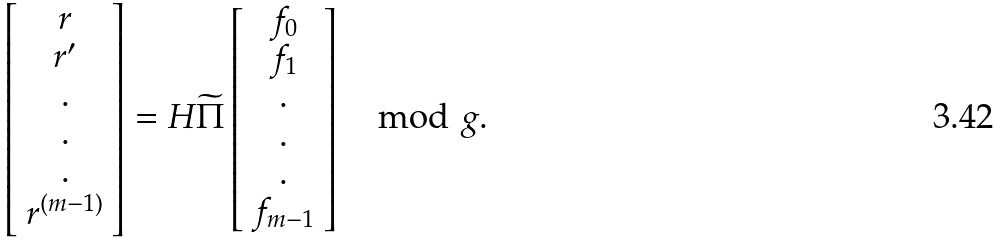Convert formula to latex. <formula><loc_0><loc_0><loc_500><loc_500>\left [ \begin{array} { c } r \\ r ^ { \prime } \\ . \\ . \\ . \\ r ^ { ( m - 1 ) } \end{array} \right ] = H \widetilde { \Pi } \left [ \begin{array} { c } f _ { 0 } \\ f _ { 1 } \\ . \\ . \\ . \\ f _ { m - 1 } \end{array} \right ] \mod g .</formula> 